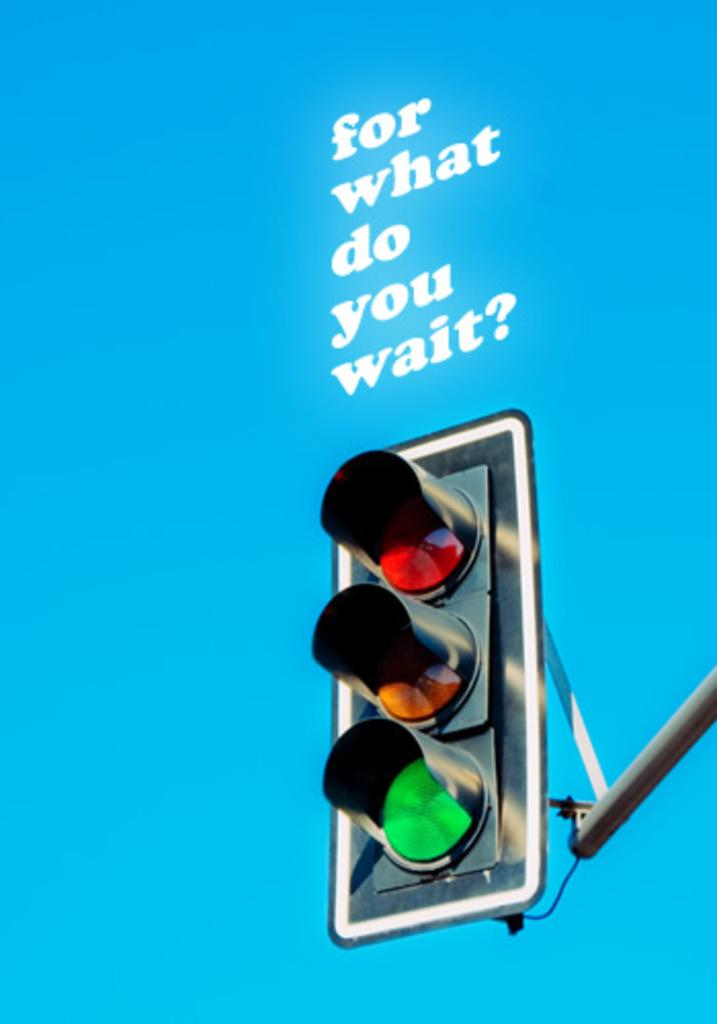<image>
Give a short and clear explanation of the subsequent image. a light below a for what do you wait sign 